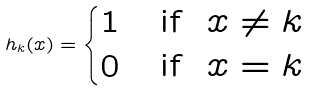Convert formula to latex. <formula><loc_0><loc_0><loc_500><loc_500>h _ { k } ( x ) = \begin{cases} 1 & \text {if \ $x \neq k$} \\ 0 & \text {if \ $x = k$} \end{cases}</formula> 